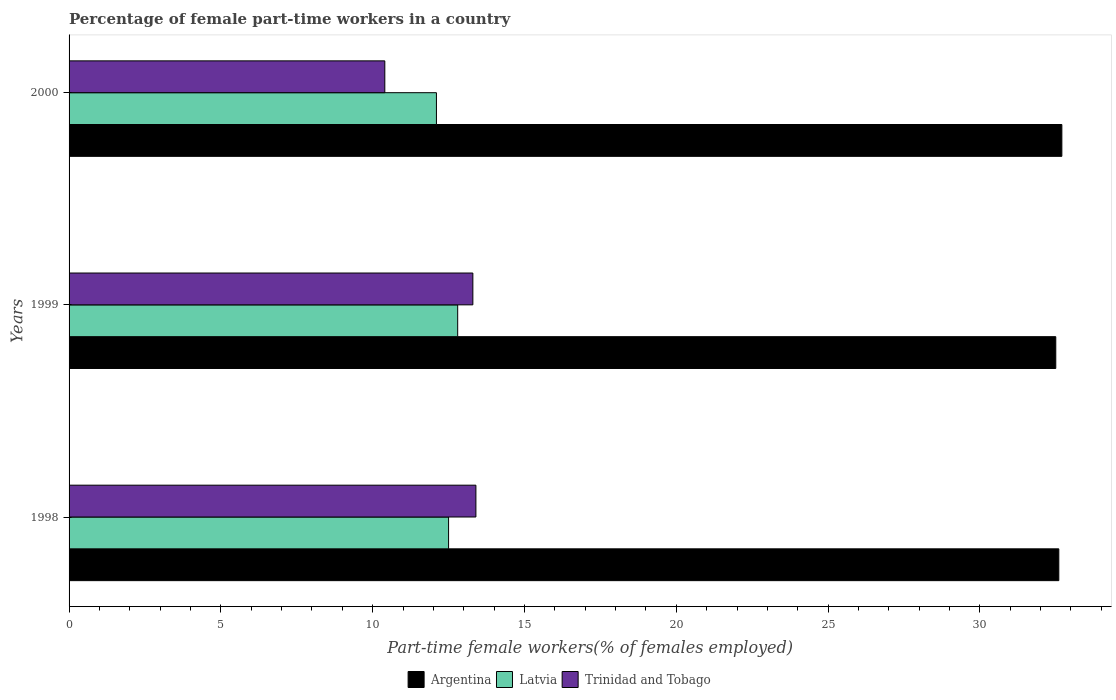How many different coloured bars are there?
Make the answer very short. 3. How many groups of bars are there?
Your answer should be compact. 3. In how many cases, is the number of bars for a given year not equal to the number of legend labels?
Provide a short and direct response. 0. What is the percentage of female part-time workers in Argentina in 1998?
Ensure brevity in your answer.  32.6. Across all years, what is the maximum percentage of female part-time workers in Latvia?
Provide a succinct answer. 12.8. Across all years, what is the minimum percentage of female part-time workers in Argentina?
Your answer should be very brief. 32.5. In which year was the percentage of female part-time workers in Latvia maximum?
Offer a very short reply. 1999. In which year was the percentage of female part-time workers in Trinidad and Tobago minimum?
Give a very brief answer. 2000. What is the total percentage of female part-time workers in Latvia in the graph?
Ensure brevity in your answer.  37.4. What is the difference between the percentage of female part-time workers in Argentina in 1999 and that in 2000?
Your answer should be compact. -0.2. What is the difference between the percentage of female part-time workers in Trinidad and Tobago in 2000 and the percentage of female part-time workers in Argentina in 1999?
Make the answer very short. -22.1. What is the average percentage of female part-time workers in Trinidad and Tobago per year?
Provide a short and direct response. 12.37. In the year 1999, what is the difference between the percentage of female part-time workers in Trinidad and Tobago and percentage of female part-time workers in Argentina?
Your answer should be compact. -19.2. In how many years, is the percentage of female part-time workers in Latvia greater than 1 %?
Your response must be concise. 3. What is the ratio of the percentage of female part-time workers in Argentina in 1998 to that in 1999?
Give a very brief answer. 1. What is the difference between the highest and the second highest percentage of female part-time workers in Trinidad and Tobago?
Provide a succinct answer. 0.1. In how many years, is the percentage of female part-time workers in Latvia greater than the average percentage of female part-time workers in Latvia taken over all years?
Your response must be concise. 2. Is the sum of the percentage of female part-time workers in Trinidad and Tobago in 1999 and 2000 greater than the maximum percentage of female part-time workers in Argentina across all years?
Offer a very short reply. No. What does the 2nd bar from the top in 1999 represents?
Provide a succinct answer. Latvia. What does the 3rd bar from the bottom in 2000 represents?
Ensure brevity in your answer.  Trinidad and Tobago. How many bars are there?
Your answer should be very brief. 9. Are all the bars in the graph horizontal?
Provide a succinct answer. Yes. What is the difference between two consecutive major ticks on the X-axis?
Your response must be concise. 5. Does the graph contain grids?
Ensure brevity in your answer.  No. How many legend labels are there?
Your answer should be compact. 3. What is the title of the graph?
Make the answer very short. Percentage of female part-time workers in a country. Does "Eritrea" appear as one of the legend labels in the graph?
Keep it short and to the point. No. What is the label or title of the X-axis?
Offer a very short reply. Part-time female workers(% of females employed). What is the Part-time female workers(% of females employed) of Argentina in 1998?
Provide a short and direct response. 32.6. What is the Part-time female workers(% of females employed) in Latvia in 1998?
Provide a short and direct response. 12.5. What is the Part-time female workers(% of females employed) of Trinidad and Tobago in 1998?
Offer a very short reply. 13.4. What is the Part-time female workers(% of females employed) of Argentina in 1999?
Keep it short and to the point. 32.5. What is the Part-time female workers(% of females employed) in Latvia in 1999?
Make the answer very short. 12.8. What is the Part-time female workers(% of females employed) of Trinidad and Tobago in 1999?
Your answer should be compact. 13.3. What is the Part-time female workers(% of females employed) in Argentina in 2000?
Your answer should be compact. 32.7. What is the Part-time female workers(% of females employed) of Latvia in 2000?
Provide a short and direct response. 12.1. What is the Part-time female workers(% of females employed) of Trinidad and Tobago in 2000?
Keep it short and to the point. 10.4. Across all years, what is the maximum Part-time female workers(% of females employed) of Argentina?
Provide a succinct answer. 32.7. Across all years, what is the maximum Part-time female workers(% of females employed) in Latvia?
Offer a terse response. 12.8. Across all years, what is the maximum Part-time female workers(% of females employed) of Trinidad and Tobago?
Make the answer very short. 13.4. Across all years, what is the minimum Part-time female workers(% of females employed) of Argentina?
Your answer should be very brief. 32.5. Across all years, what is the minimum Part-time female workers(% of females employed) of Latvia?
Make the answer very short. 12.1. Across all years, what is the minimum Part-time female workers(% of females employed) in Trinidad and Tobago?
Your response must be concise. 10.4. What is the total Part-time female workers(% of females employed) of Argentina in the graph?
Provide a short and direct response. 97.8. What is the total Part-time female workers(% of females employed) of Latvia in the graph?
Offer a very short reply. 37.4. What is the total Part-time female workers(% of females employed) in Trinidad and Tobago in the graph?
Offer a very short reply. 37.1. What is the difference between the Part-time female workers(% of females employed) in Argentina in 1998 and that in 2000?
Provide a succinct answer. -0.1. What is the difference between the Part-time female workers(% of females employed) in Latvia in 1999 and that in 2000?
Provide a succinct answer. 0.7. What is the difference between the Part-time female workers(% of females employed) in Argentina in 1998 and the Part-time female workers(% of females employed) in Latvia in 1999?
Your response must be concise. 19.8. What is the difference between the Part-time female workers(% of females employed) of Argentina in 1998 and the Part-time female workers(% of females employed) of Trinidad and Tobago in 1999?
Provide a succinct answer. 19.3. What is the difference between the Part-time female workers(% of females employed) of Latvia in 1998 and the Part-time female workers(% of females employed) of Trinidad and Tobago in 1999?
Offer a terse response. -0.8. What is the difference between the Part-time female workers(% of females employed) of Argentina in 1998 and the Part-time female workers(% of females employed) of Trinidad and Tobago in 2000?
Make the answer very short. 22.2. What is the difference between the Part-time female workers(% of females employed) in Latvia in 1998 and the Part-time female workers(% of females employed) in Trinidad and Tobago in 2000?
Keep it short and to the point. 2.1. What is the difference between the Part-time female workers(% of females employed) of Argentina in 1999 and the Part-time female workers(% of females employed) of Latvia in 2000?
Offer a very short reply. 20.4. What is the difference between the Part-time female workers(% of females employed) of Argentina in 1999 and the Part-time female workers(% of females employed) of Trinidad and Tobago in 2000?
Keep it short and to the point. 22.1. What is the average Part-time female workers(% of females employed) in Argentina per year?
Provide a succinct answer. 32.6. What is the average Part-time female workers(% of females employed) in Latvia per year?
Ensure brevity in your answer.  12.47. What is the average Part-time female workers(% of females employed) of Trinidad and Tobago per year?
Keep it short and to the point. 12.37. In the year 1998, what is the difference between the Part-time female workers(% of females employed) in Argentina and Part-time female workers(% of females employed) in Latvia?
Give a very brief answer. 20.1. In the year 1998, what is the difference between the Part-time female workers(% of females employed) in Argentina and Part-time female workers(% of females employed) in Trinidad and Tobago?
Make the answer very short. 19.2. In the year 1998, what is the difference between the Part-time female workers(% of females employed) in Latvia and Part-time female workers(% of females employed) in Trinidad and Tobago?
Offer a terse response. -0.9. In the year 1999, what is the difference between the Part-time female workers(% of females employed) of Argentina and Part-time female workers(% of females employed) of Trinidad and Tobago?
Make the answer very short. 19.2. In the year 2000, what is the difference between the Part-time female workers(% of females employed) in Argentina and Part-time female workers(% of females employed) in Latvia?
Provide a short and direct response. 20.6. In the year 2000, what is the difference between the Part-time female workers(% of females employed) in Argentina and Part-time female workers(% of females employed) in Trinidad and Tobago?
Offer a terse response. 22.3. In the year 2000, what is the difference between the Part-time female workers(% of females employed) in Latvia and Part-time female workers(% of females employed) in Trinidad and Tobago?
Offer a very short reply. 1.7. What is the ratio of the Part-time female workers(% of females employed) of Latvia in 1998 to that in 1999?
Your answer should be compact. 0.98. What is the ratio of the Part-time female workers(% of females employed) in Trinidad and Tobago in 1998 to that in 1999?
Keep it short and to the point. 1.01. What is the ratio of the Part-time female workers(% of females employed) of Argentina in 1998 to that in 2000?
Provide a short and direct response. 1. What is the ratio of the Part-time female workers(% of females employed) of Latvia in 1998 to that in 2000?
Provide a short and direct response. 1.03. What is the ratio of the Part-time female workers(% of females employed) in Trinidad and Tobago in 1998 to that in 2000?
Provide a short and direct response. 1.29. What is the ratio of the Part-time female workers(% of females employed) of Latvia in 1999 to that in 2000?
Provide a short and direct response. 1.06. What is the ratio of the Part-time female workers(% of females employed) in Trinidad and Tobago in 1999 to that in 2000?
Offer a terse response. 1.28. What is the difference between the highest and the second highest Part-time female workers(% of females employed) in Trinidad and Tobago?
Your answer should be very brief. 0.1. What is the difference between the highest and the lowest Part-time female workers(% of females employed) of Latvia?
Give a very brief answer. 0.7. What is the difference between the highest and the lowest Part-time female workers(% of females employed) in Trinidad and Tobago?
Provide a succinct answer. 3. 